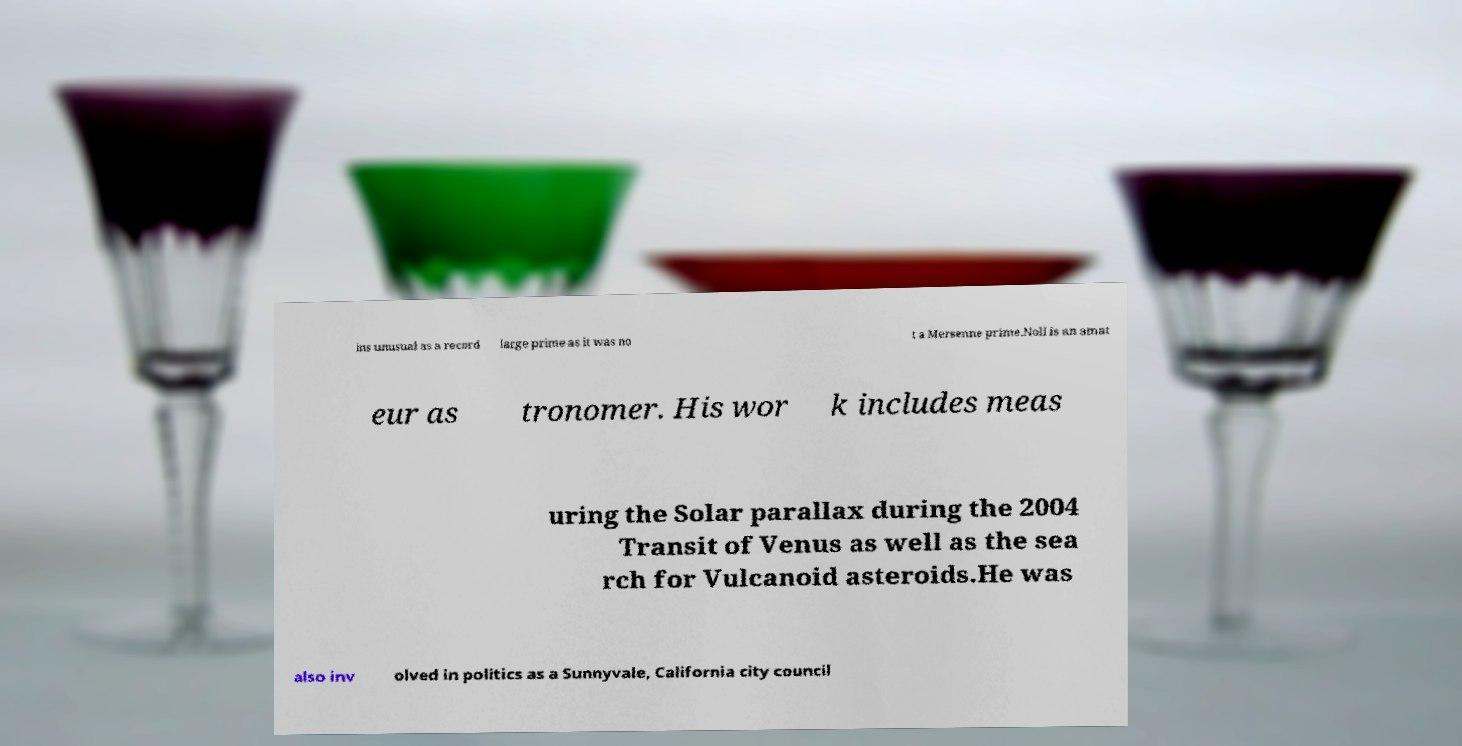Could you extract and type out the text from this image? ins unusual as a record large prime as it was no t a Mersenne prime.Noll is an amat eur as tronomer. His wor k includes meas uring the Solar parallax during the 2004 Transit of Venus as well as the sea rch for Vulcanoid asteroids.He was also inv olved in politics as a Sunnyvale, California city council 